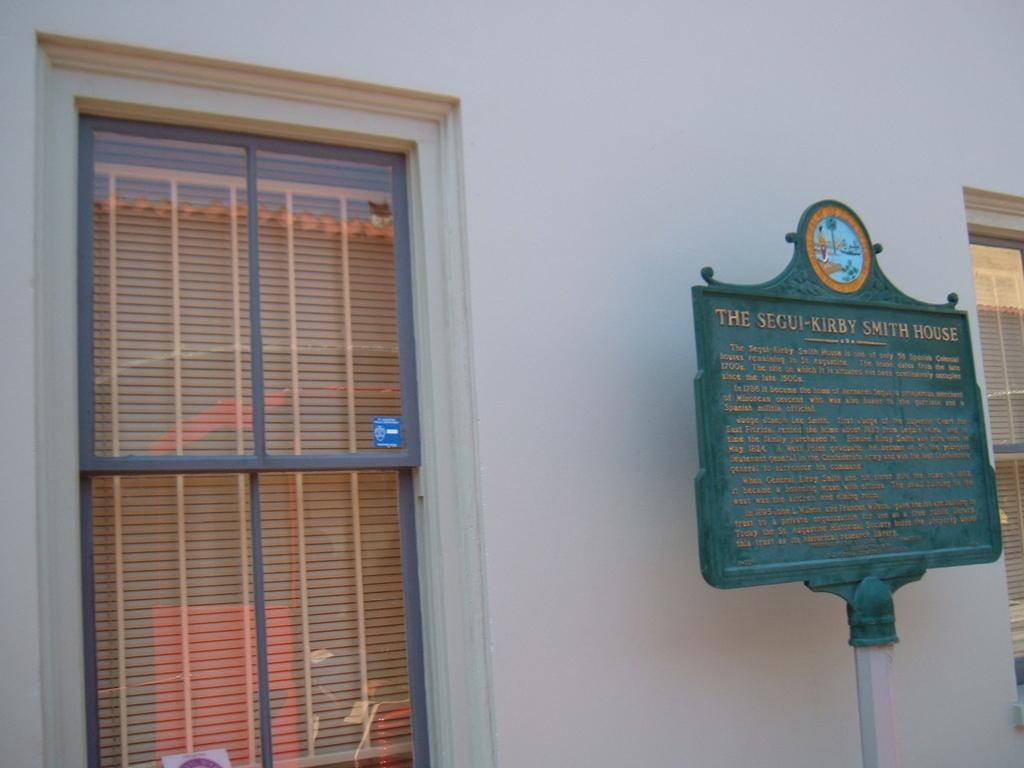<image>
Summarize the visual content of the image. A green sign advertises The Segui-Kirby Smith House. 